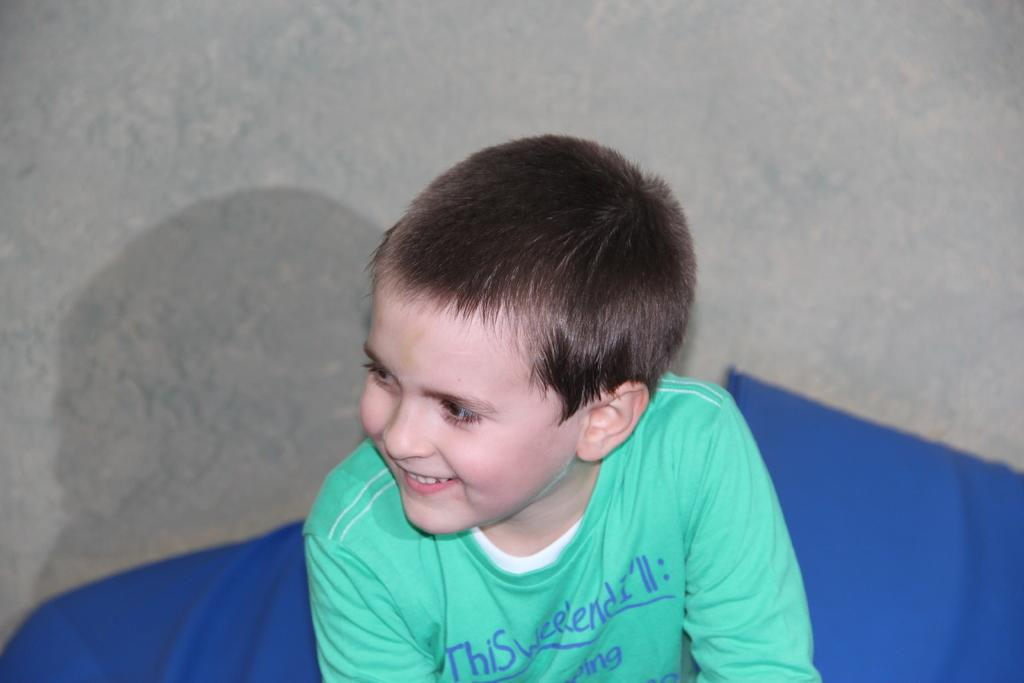What is the main subject in the foreground of the image? There is a boy in the foreground of the image. What is on the floor near the boy? There is a cloth on the floor in the foreground. Where was the image taken? The image was taken in a room. What type of box can be seen in the image? There is no box present in the image. What drink is the boy holding in the image? The boy is not holding any drink in the image. 